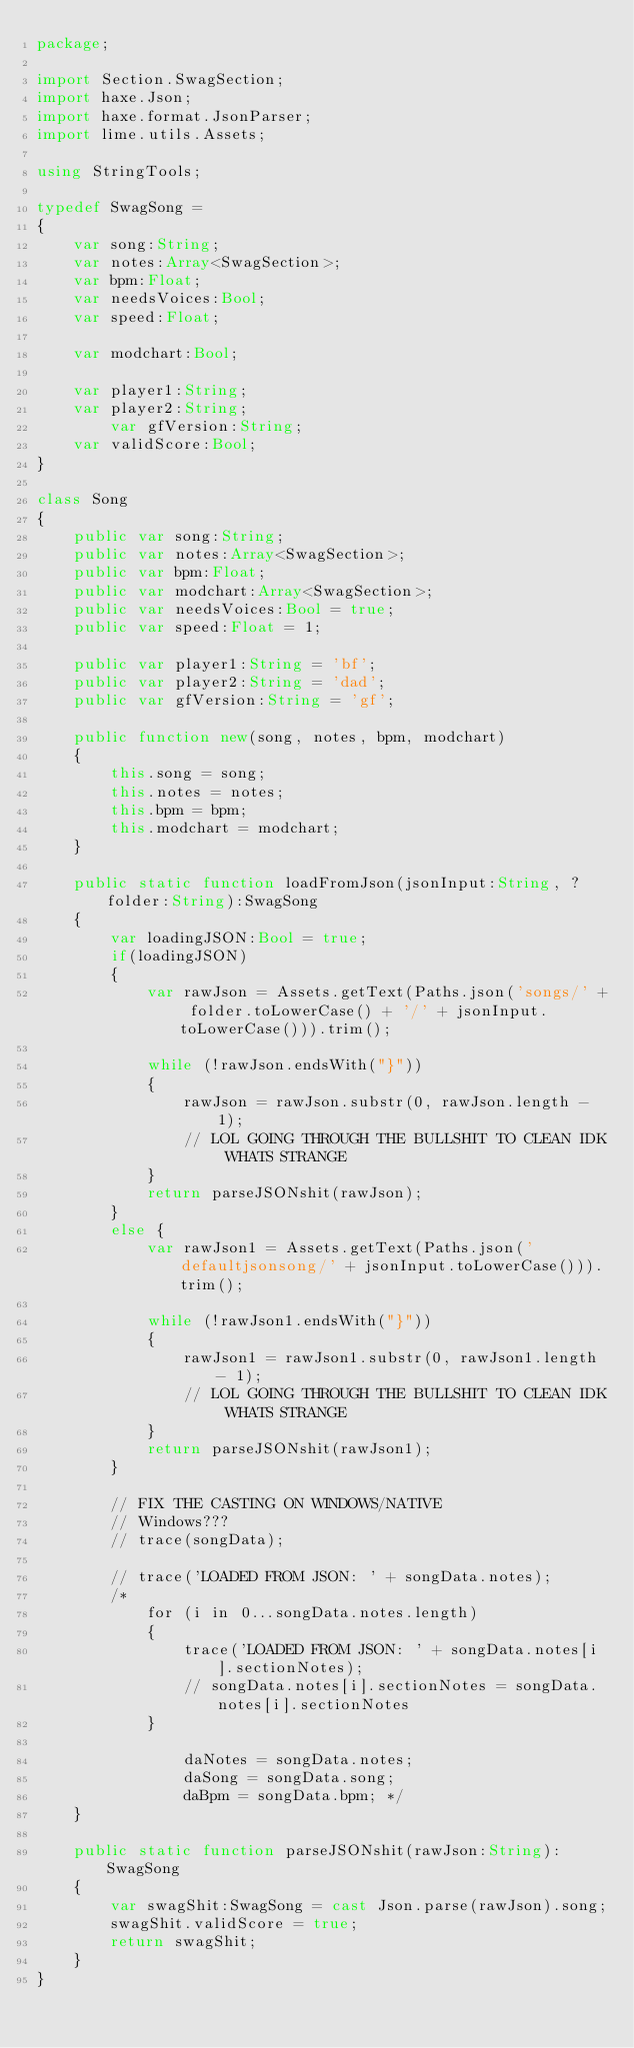<code> <loc_0><loc_0><loc_500><loc_500><_Haxe_>package;

import Section.SwagSection;
import haxe.Json;
import haxe.format.JsonParser;
import lime.utils.Assets;

using StringTools;

typedef SwagSong =
{
	var song:String;
	var notes:Array<SwagSection>;
	var bpm:Float;
	var needsVoices:Bool;
	var speed:Float;

	var modchart:Bool;

	var player1:String;
	var player2:String;
        var gfVersion:String;
	var validScore:Bool;
}

class Song
{
	public var song:String;
	public var notes:Array<SwagSection>;
	public var bpm:Float;
	public var modchart:Array<SwagSection>;
	public var needsVoices:Bool = true;
	public var speed:Float = 1;

	public var player1:String = 'bf';
	public var player2:String = 'dad';
    public var gfVersion:String = 'gf';

	public function new(song, notes, bpm, modchart)
	{
		this.song = song;
		this.notes = notes;
		this.bpm = bpm;
		this.modchart = modchart;
	}

	public static function loadFromJson(jsonInput:String, ?folder:String):SwagSong
	{
		var loadingJSON:Bool = true;
		if(loadingJSON)
		{
			var rawJson = Assets.getText(Paths.json('songs/' + folder.toLowerCase() + '/' + jsonInput.toLowerCase())).trim();

			while (!rawJson.endsWith("}"))
			{
				rawJson = rawJson.substr(0, rawJson.length - 1);
				// LOL GOING THROUGH THE BULLSHIT TO CLEAN IDK WHATS STRANGE
			}
			return parseJSONshit(rawJson);
		}
		else {
			var rawJson1 = Assets.getText(Paths.json('defaultjsonsong/' + jsonInput.toLowerCase())).trim();

			while (!rawJson1.endsWith("}"))
			{
				rawJson1 = rawJson1.substr(0, rawJson1.length - 1);
				// LOL GOING THROUGH THE BULLSHIT TO CLEAN IDK WHATS STRANGE
			}
			return parseJSONshit(rawJson1);
		}

		// FIX THE CASTING ON WINDOWS/NATIVE
		// Windows???
		// trace(songData);

		// trace('LOADED FROM JSON: ' + songData.notes);
		/* 
			for (i in 0...songData.notes.length)
			{
				trace('LOADED FROM JSON: ' + songData.notes[i].sectionNotes);
				// songData.notes[i].sectionNotes = songData.notes[i].sectionNotes
			}

				daNotes = songData.notes;
				daSong = songData.song;
				daBpm = songData.bpm; */
	}

	public static function parseJSONshit(rawJson:String):SwagSong
	{
		var swagShit:SwagSong = cast Json.parse(rawJson).song;
		swagShit.validScore = true;
		return swagShit;
	}
}
</code> 